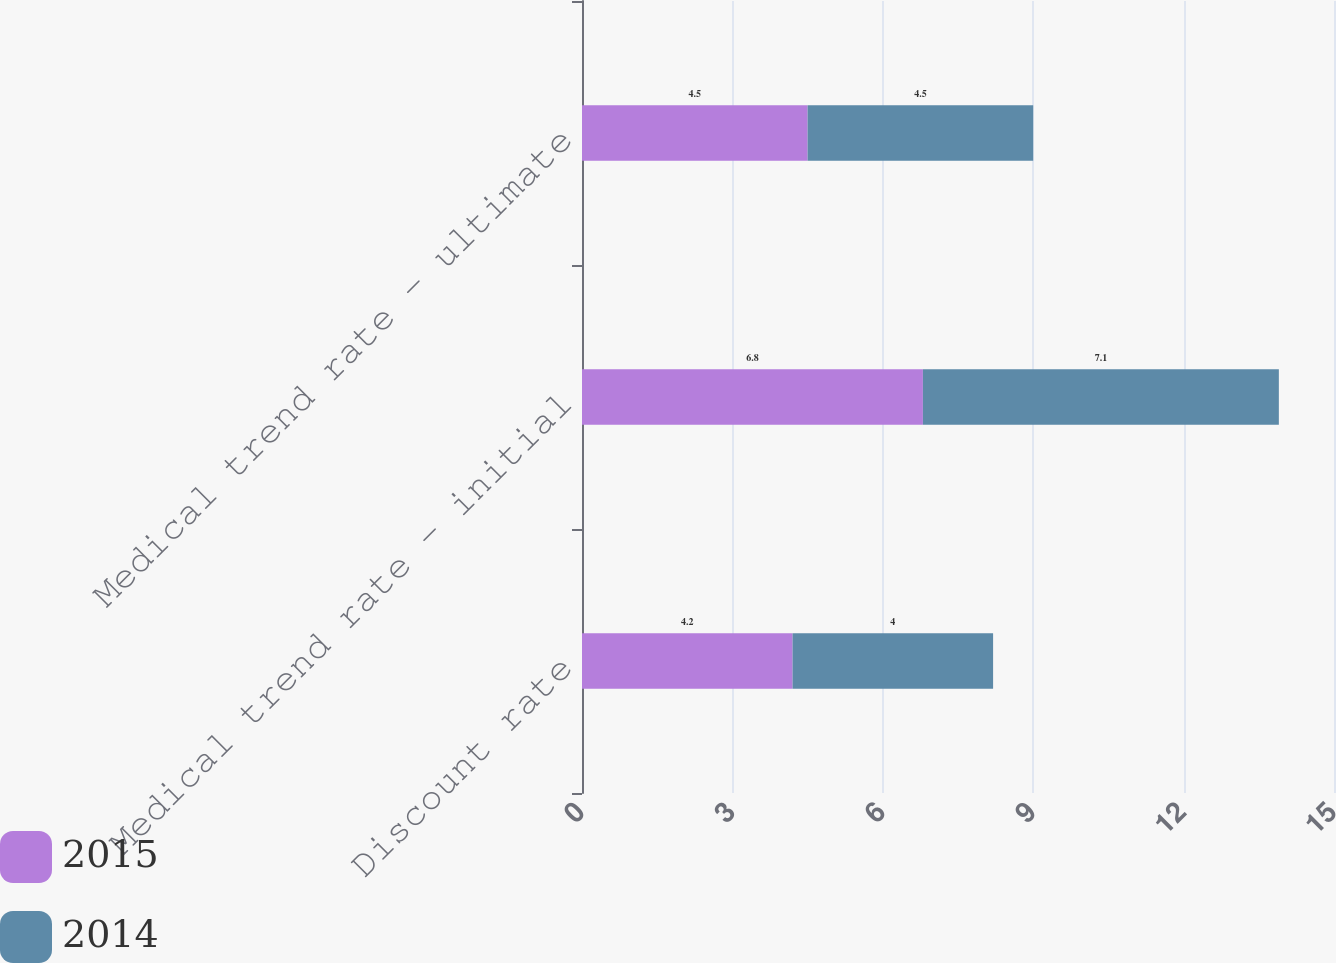Convert chart to OTSL. <chart><loc_0><loc_0><loc_500><loc_500><stacked_bar_chart><ecel><fcel>Discount rate<fcel>Medical trend rate - initial<fcel>Medical trend rate - ultimate<nl><fcel>2015<fcel>4.2<fcel>6.8<fcel>4.5<nl><fcel>2014<fcel>4<fcel>7.1<fcel>4.5<nl></chart> 